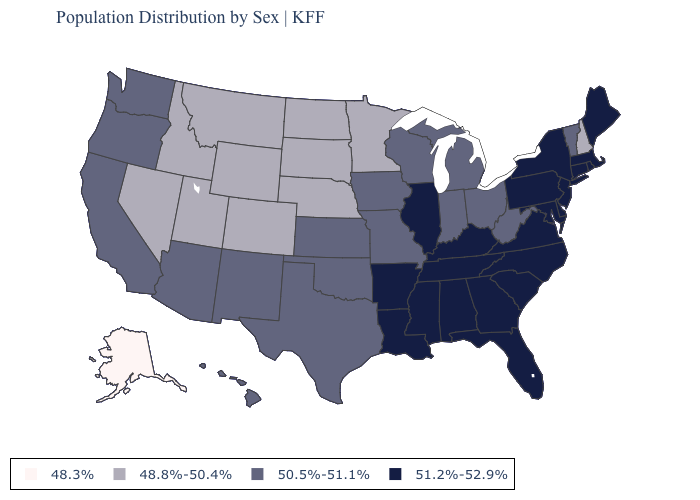Among the states that border Illinois , does Kentucky have the lowest value?
Concise answer only. No. Name the states that have a value in the range 48.3%?
Short answer required. Alaska. Name the states that have a value in the range 51.2%-52.9%?
Give a very brief answer. Alabama, Arkansas, Connecticut, Delaware, Florida, Georgia, Illinois, Kentucky, Louisiana, Maine, Maryland, Massachusetts, Mississippi, New Jersey, New York, North Carolina, Pennsylvania, Rhode Island, South Carolina, Tennessee, Virginia. Does Vermont have the same value as Oregon?
Keep it brief. Yes. Name the states that have a value in the range 51.2%-52.9%?
Short answer required. Alabama, Arkansas, Connecticut, Delaware, Florida, Georgia, Illinois, Kentucky, Louisiana, Maine, Maryland, Massachusetts, Mississippi, New Jersey, New York, North Carolina, Pennsylvania, Rhode Island, South Carolina, Tennessee, Virginia. Does Iowa have the highest value in the MidWest?
Keep it brief. No. Name the states that have a value in the range 51.2%-52.9%?
Be succinct. Alabama, Arkansas, Connecticut, Delaware, Florida, Georgia, Illinois, Kentucky, Louisiana, Maine, Maryland, Massachusetts, Mississippi, New Jersey, New York, North Carolina, Pennsylvania, Rhode Island, South Carolina, Tennessee, Virginia. What is the value of South Carolina?
Quick response, please. 51.2%-52.9%. Does Alaska have a higher value than New York?
Concise answer only. No. How many symbols are there in the legend?
Short answer required. 4. What is the value of Arizona?
Answer briefly. 50.5%-51.1%. What is the value of New Mexico?
Write a very short answer. 50.5%-51.1%. What is the lowest value in the USA?
Short answer required. 48.3%. 